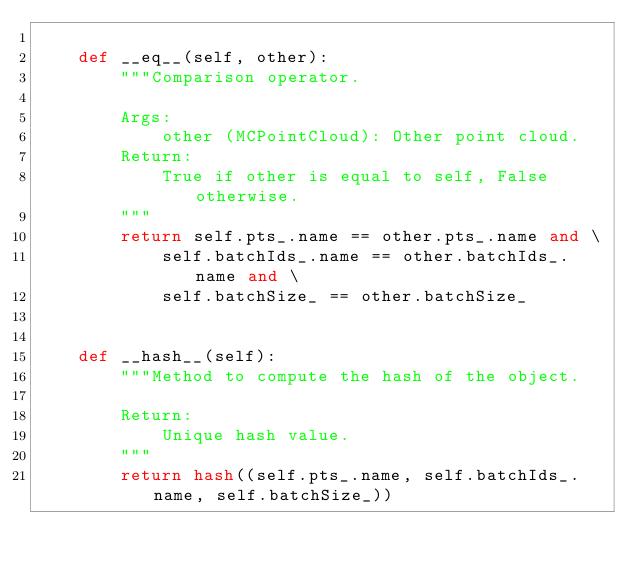<code> <loc_0><loc_0><loc_500><loc_500><_Python_>
    def __eq__(self, other):
        """Comparison operator.

        Args:
            other (MCPointCloud): Other point cloud.
        Return:
            True if other is equal to self, False otherwise.
        """
        return self.pts_.name == other.pts_.name and \
            self.batchIds_.name == other.batchIds_.name and \
            self.batchSize_ == other.batchSize_


    def __hash__(self):
        """Method to compute the hash of the object.

        Return:
            Unique hash value.
        """
        return hash((self.pts_.name, self.batchIds_.name, self.batchSize_))</code> 